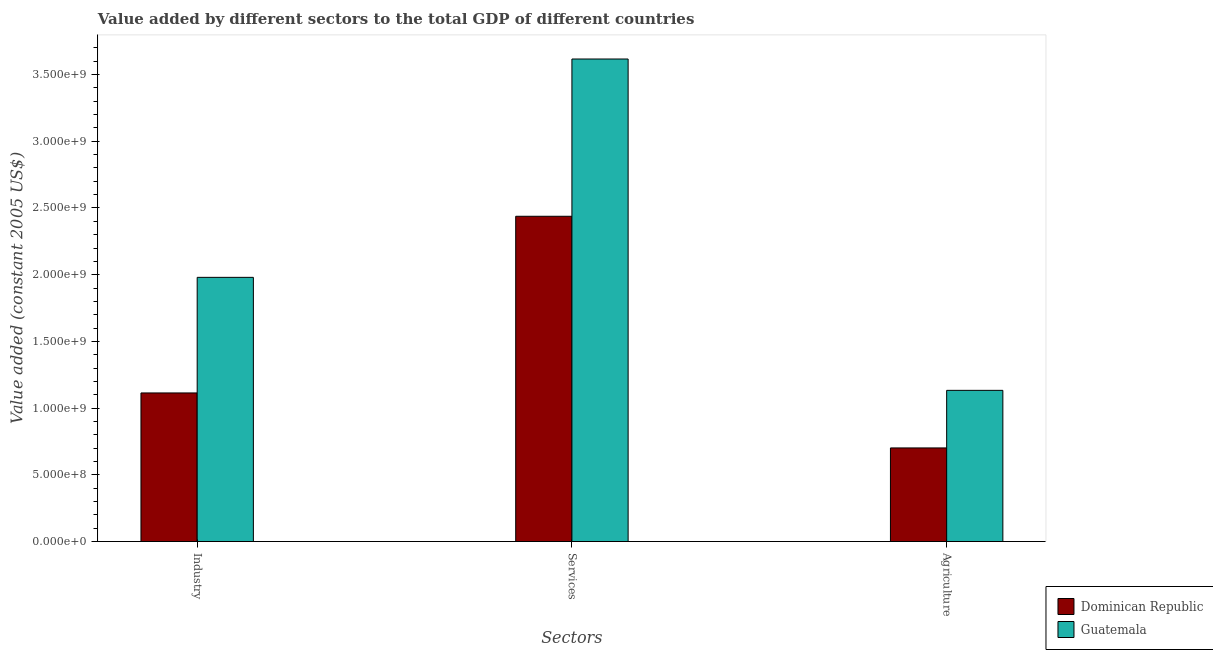How many groups of bars are there?
Give a very brief answer. 3. Are the number of bars per tick equal to the number of legend labels?
Offer a terse response. Yes. How many bars are there on the 2nd tick from the right?
Provide a succinct answer. 2. What is the label of the 2nd group of bars from the left?
Your answer should be very brief. Services. What is the value added by services in Dominican Republic?
Your answer should be very brief. 2.44e+09. Across all countries, what is the maximum value added by agricultural sector?
Provide a short and direct response. 1.13e+09. Across all countries, what is the minimum value added by agricultural sector?
Offer a very short reply. 7.02e+08. In which country was the value added by industrial sector maximum?
Make the answer very short. Guatemala. In which country was the value added by industrial sector minimum?
Give a very brief answer. Dominican Republic. What is the total value added by services in the graph?
Offer a very short reply. 6.05e+09. What is the difference between the value added by services in Guatemala and that in Dominican Republic?
Offer a very short reply. 1.18e+09. What is the difference between the value added by services in Dominican Republic and the value added by agricultural sector in Guatemala?
Make the answer very short. 1.30e+09. What is the average value added by services per country?
Make the answer very short. 3.03e+09. What is the difference between the value added by industrial sector and value added by services in Guatemala?
Your answer should be very brief. -1.64e+09. In how many countries, is the value added by industrial sector greater than 900000000 US$?
Your response must be concise. 2. What is the ratio of the value added by services in Guatemala to that in Dominican Republic?
Provide a succinct answer. 1.48. Is the value added by agricultural sector in Guatemala less than that in Dominican Republic?
Offer a terse response. No. What is the difference between the highest and the second highest value added by services?
Make the answer very short. 1.18e+09. What is the difference between the highest and the lowest value added by industrial sector?
Provide a short and direct response. 8.66e+08. What does the 2nd bar from the left in Agriculture represents?
Provide a succinct answer. Guatemala. What does the 2nd bar from the right in Agriculture represents?
Ensure brevity in your answer.  Dominican Republic. How many bars are there?
Your answer should be very brief. 6. How many countries are there in the graph?
Your answer should be compact. 2. Are the values on the major ticks of Y-axis written in scientific E-notation?
Ensure brevity in your answer.  Yes. How many legend labels are there?
Ensure brevity in your answer.  2. What is the title of the graph?
Ensure brevity in your answer.  Value added by different sectors to the total GDP of different countries. What is the label or title of the X-axis?
Give a very brief answer. Sectors. What is the label or title of the Y-axis?
Make the answer very short. Value added (constant 2005 US$). What is the Value added (constant 2005 US$) in Dominican Republic in Industry?
Your response must be concise. 1.11e+09. What is the Value added (constant 2005 US$) of Guatemala in Industry?
Your response must be concise. 1.98e+09. What is the Value added (constant 2005 US$) in Dominican Republic in Services?
Keep it short and to the point. 2.44e+09. What is the Value added (constant 2005 US$) of Guatemala in Services?
Give a very brief answer. 3.62e+09. What is the Value added (constant 2005 US$) of Dominican Republic in Agriculture?
Make the answer very short. 7.02e+08. What is the Value added (constant 2005 US$) in Guatemala in Agriculture?
Keep it short and to the point. 1.13e+09. Across all Sectors, what is the maximum Value added (constant 2005 US$) in Dominican Republic?
Offer a terse response. 2.44e+09. Across all Sectors, what is the maximum Value added (constant 2005 US$) of Guatemala?
Ensure brevity in your answer.  3.62e+09. Across all Sectors, what is the minimum Value added (constant 2005 US$) of Dominican Republic?
Offer a terse response. 7.02e+08. Across all Sectors, what is the minimum Value added (constant 2005 US$) in Guatemala?
Offer a terse response. 1.13e+09. What is the total Value added (constant 2005 US$) of Dominican Republic in the graph?
Provide a short and direct response. 4.25e+09. What is the total Value added (constant 2005 US$) in Guatemala in the graph?
Give a very brief answer. 6.73e+09. What is the difference between the Value added (constant 2005 US$) of Dominican Republic in Industry and that in Services?
Offer a very short reply. -1.32e+09. What is the difference between the Value added (constant 2005 US$) in Guatemala in Industry and that in Services?
Offer a terse response. -1.64e+09. What is the difference between the Value added (constant 2005 US$) of Dominican Republic in Industry and that in Agriculture?
Offer a very short reply. 4.12e+08. What is the difference between the Value added (constant 2005 US$) of Guatemala in Industry and that in Agriculture?
Your response must be concise. 8.47e+08. What is the difference between the Value added (constant 2005 US$) of Dominican Republic in Services and that in Agriculture?
Your answer should be very brief. 1.74e+09. What is the difference between the Value added (constant 2005 US$) in Guatemala in Services and that in Agriculture?
Keep it short and to the point. 2.48e+09. What is the difference between the Value added (constant 2005 US$) of Dominican Republic in Industry and the Value added (constant 2005 US$) of Guatemala in Services?
Offer a very short reply. -2.50e+09. What is the difference between the Value added (constant 2005 US$) of Dominican Republic in Industry and the Value added (constant 2005 US$) of Guatemala in Agriculture?
Offer a very short reply. -1.95e+07. What is the difference between the Value added (constant 2005 US$) in Dominican Republic in Services and the Value added (constant 2005 US$) in Guatemala in Agriculture?
Your response must be concise. 1.30e+09. What is the average Value added (constant 2005 US$) in Dominican Republic per Sectors?
Provide a short and direct response. 1.42e+09. What is the average Value added (constant 2005 US$) of Guatemala per Sectors?
Ensure brevity in your answer.  2.24e+09. What is the difference between the Value added (constant 2005 US$) in Dominican Republic and Value added (constant 2005 US$) in Guatemala in Industry?
Your answer should be compact. -8.66e+08. What is the difference between the Value added (constant 2005 US$) of Dominican Republic and Value added (constant 2005 US$) of Guatemala in Services?
Offer a very short reply. -1.18e+09. What is the difference between the Value added (constant 2005 US$) of Dominican Republic and Value added (constant 2005 US$) of Guatemala in Agriculture?
Provide a succinct answer. -4.32e+08. What is the ratio of the Value added (constant 2005 US$) of Dominican Republic in Industry to that in Services?
Provide a succinct answer. 0.46. What is the ratio of the Value added (constant 2005 US$) in Guatemala in Industry to that in Services?
Your answer should be very brief. 0.55. What is the ratio of the Value added (constant 2005 US$) in Dominican Republic in Industry to that in Agriculture?
Your response must be concise. 1.59. What is the ratio of the Value added (constant 2005 US$) in Guatemala in Industry to that in Agriculture?
Make the answer very short. 1.75. What is the ratio of the Value added (constant 2005 US$) of Dominican Republic in Services to that in Agriculture?
Offer a very short reply. 3.47. What is the ratio of the Value added (constant 2005 US$) in Guatemala in Services to that in Agriculture?
Offer a very short reply. 3.19. What is the difference between the highest and the second highest Value added (constant 2005 US$) in Dominican Republic?
Your answer should be compact. 1.32e+09. What is the difference between the highest and the second highest Value added (constant 2005 US$) of Guatemala?
Give a very brief answer. 1.64e+09. What is the difference between the highest and the lowest Value added (constant 2005 US$) in Dominican Republic?
Provide a short and direct response. 1.74e+09. What is the difference between the highest and the lowest Value added (constant 2005 US$) in Guatemala?
Keep it short and to the point. 2.48e+09. 